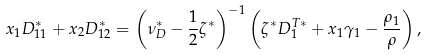<formula> <loc_0><loc_0><loc_500><loc_500>x _ { 1 } D _ { 1 1 } ^ { * } + x _ { 2 } D _ { 1 2 } ^ { * } = \left ( \nu _ { D } ^ { * } - \frac { 1 } { 2 } \zeta ^ { * } \right ) ^ { - 1 } \left ( \zeta ^ { * } D _ { 1 } ^ { T * } + x _ { 1 } \gamma _ { 1 } - \frac { \rho _ { 1 } } { \rho } \right ) ,</formula> 